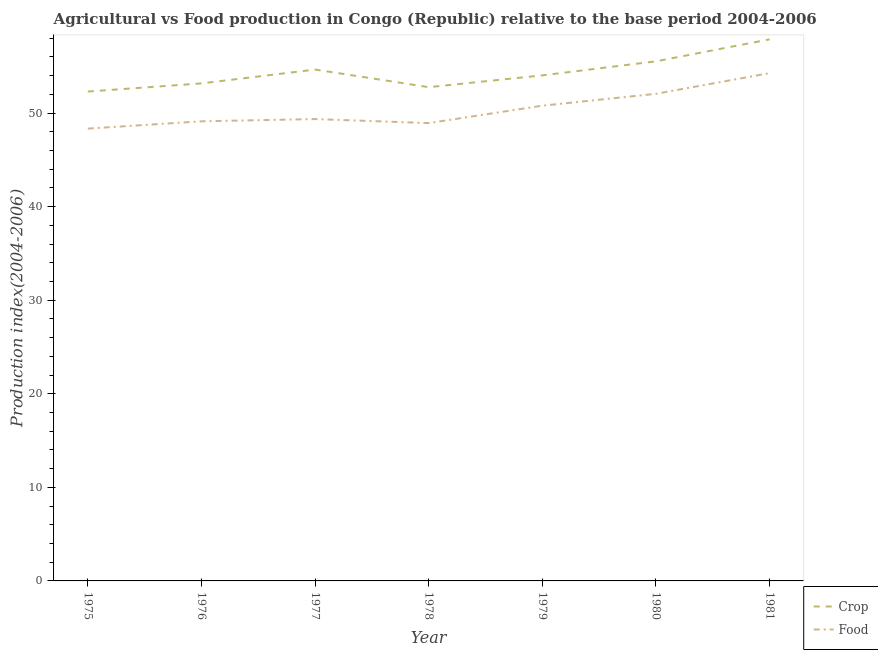Does the line corresponding to food production index intersect with the line corresponding to crop production index?
Provide a short and direct response. No. What is the crop production index in 1975?
Give a very brief answer. 52.3. Across all years, what is the maximum food production index?
Your response must be concise. 54.27. Across all years, what is the minimum food production index?
Ensure brevity in your answer.  48.34. In which year was the crop production index maximum?
Your answer should be very brief. 1981. In which year was the food production index minimum?
Provide a succinct answer. 1975. What is the total crop production index in the graph?
Your response must be concise. 380.33. What is the difference between the crop production index in 1980 and that in 1981?
Make the answer very short. -2.35. What is the difference between the crop production index in 1978 and the food production index in 1975?
Provide a succinct answer. 4.43. What is the average food production index per year?
Give a very brief answer. 50.41. In the year 1978, what is the difference between the food production index and crop production index?
Your response must be concise. -3.84. In how many years, is the crop production index greater than 22?
Make the answer very short. 7. What is the ratio of the crop production index in 1976 to that in 1980?
Keep it short and to the point. 0.96. Is the food production index in 1975 less than that in 1978?
Give a very brief answer. Yes. What is the difference between the highest and the second highest crop production index?
Provide a short and direct response. 2.35. What is the difference between the highest and the lowest crop production index?
Make the answer very short. 5.58. In how many years, is the crop production index greater than the average crop production index taken over all years?
Offer a terse response. 3. How many years are there in the graph?
Your answer should be compact. 7. What is the difference between two consecutive major ticks on the Y-axis?
Your answer should be very brief. 10. Where does the legend appear in the graph?
Offer a very short reply. Bottom right. What is the title of the graph?
Offer a very short reply. Agricultural vs Food production in Congo (Republic) relative to the base period 2004-2006. What is the label or title of the X-axis?
Your answer should be very brief. Year. What is the label or title of the Y-axis?
Your response must be concise. Production index(2004-2006). What is the Production index(2004-2006) in Crop in 1975?
Give a very brief answer. 52.3. What is the Production index(2004-2006) in Food in 1975?
Your answer should be compact. 48.34. What is the Production index(2004-2006) in Crop in 1976?
Make the answer very short. 53.17. What is the Production index(2004-2006) in Food in 1976?
Provide a short and direct response. 49.12. What is the Production index(2004-2006) of Crop in 1977?
Your answer should be very brief. 54.65. What is the Production index(2004-2006) in Food in 1977?
Your answer should be compact. 49.36. What is the Production index(2004-2006) in Crop in 1978?
Offer a terse response. 52.77. What is the Production index(2004-2006) in Food in 1978?
Give a very brief answer. 48.93. What is the Production index(2004-2006) in Crop in 1979?
Provide a succinct answer. 54.03. What is the Production index(2004-2006) of Food in 1979?
Offer a very short reply. 50.79. What is the Production index(2004-2006) in Crop in 1980?
Your response must be concise. 55.53. What is the Production index(2004-2006) of Food in 1980?
Provide a succinct answer. 52.06. What is the Production index(2004-2006) in Crop in 1981?
Keep it short and to the point. 57.88. What is the Production index(2004-2006) in Food in 1981?
Provide a succinct answer. 54.27. Across all years, what is the maximum Production index(2004-2006) of Crop?
Your answer should be compact. 57.88. Across all years, what is the maximum Production index(2004-2006) in Food?
Your answer should be very brief. 54.27. Across all years, what is the minimum Production index(2004-2006) of Crop?
Your response must be concise. 52.3. Across all years, what is the minimum Production index(2004-2006) of Food?
Give a very brief answer. 48.34. What is the total Production index(2004-2006) in Crop in the graph?
Your answer should be very brief. 380.33. What is the total Production index(2004-2006) of Food in the graph?
Ensure brevity in your answer.  352.87. What is the difference between the Production index(2004-2006) in Crop in 1975 and that in 1976?
Your response must be concise. -0.87. What is the difference between the Production index(2004-2006) in Food in 1975 and that in 1976?
Your response must be concise. -0.78. What is the difference between the Production index(2004-2006) in Crop in 1975 and that in 1977?
Offer a terse response. -2.35. What is the difference between the Production index(2004-2006) in Food in 1975 and that in 1977?
Your answer should be very brief. -1.02. What is the difference between the Production index(2004-2006) of Crop in 1975 and that in 1978?
Your answer should be very brief. -0.47. What is the difference between the Production index(2004-2006) in Food in 1975 and that in 1978?
Offer a very short reply. -0.59. What is the difference between the Production index(2004-2006) in Crop in 1975 and that in 1979?
Make the answer very short. -1.73. What is the difference between the Production index(2004-2006) of Food in 1975 and that in 1979?
Provide a short and direct response. -2.45. What is the difference between the Production index(2004-2006) of Crop in 1975 and that in 1980?
Provide a short and direct response. -3.23. What is the difference between the Production index(2004-2006) in Food in 1975 and that in 1980?
Give a very brief answer. -3.72. What is the difference between the Production index(2004-2006) in Crop in 1975 and that in 1981?
Provide a succinct answer. -5.58. What is the difference between the Production index(2004-2006) of Food in 1975 and that in 1981?
Your answer should be compact. -5.93. What is the difference between the Production index(2004-2006) in Crop in 1976 and that in 1977?
Your answer should be very brief. -1.48. What is the difference between the Production index(2004-2006) in Food in 1976 and that in 1977?
Keep it short and to the point. -0.24. What is the difference between the Production index(2004-2006) in Food in 1976 and that in 1978?
Your answer should be very brief. 0.19. What is the difference between the Production index(2004-2006) of Crop in 1976 and that in 1979?
Your answer should be very brief. -0.86. What is the difference between the Production index(2004-2006) in Food in 1976 and that in 1979?
Make the answer very short. -1.67. What is the difference between the Production index(2004-2006) of Crop in 1976 and that in 1980?
Give a very brief answer. -2.36. What is the difference between the Production index(2004-2006) in Food in 1976 and that in 1980?
Provide a succinct answer. -2.94. What is the difference between the Production index(2004-2006) of Crop in 1976 and that in 1981?
Give a very brief answer. -4.71. What is the difference between the Production index(2004-2006) of Food in 1976 and that in 1981?
Keep it short and to the point. -5.15. What is the difference between the Production index(2004-2006) of Crop in 1977 and that in 1978?
Provide a succinct answer. 1.88. What is the difference between the Production index(2004-2006) in Food in 1977 and that in 1978?
Keep it short and to the point. 0.43. What is the difference between the Production index(2004-2006) in Crop in 1977 and that in 1979?
Keep it short and to the point. 0.62. What is the difference between the Production index(2004-2006) of Food in 1977 and that in 1979?
Provide a succinct answer. -1.43. What is the difference between the Production index(2004-2006) in Crop in 1977 and that in 1980?
Provide a short and direct response. -0.88. What is the difference between the Production index(2004-2006) in Food in 1977 and that in 1980?
Your answer should be compact. -2.7. What is the difference between the Production index(2004-2006) in Crop in 1977 and that in 1981?
Provide a succinct answer. -3.23. What is the difference between the Production index(2004-2006) in Food in 1977 and that in 1981?
Your answer should be very brief. -4.91. What is the difference between the Production index(2004-2006) in Crop in 1978 and that in 1979?
Give a very brief answer. -1.26. What is the difference between the Production index(2004-2006) in Food in 1978 and that in 1979?
Provide a short and direct response. -1.86. What is the difference between the Production index(2004-2006) of Crop in 1978 and that in 1980?
Provide a short and direct response. -2.76. What is the difference between the Production index(2004-2006) of Food in 1978 and that in 1980?
Make the answer very short. -3.13. What is the difference between the Production index(2004-2006) in Crop in 1978 and that in 1981?
Your answer should be very brief. -5.11. What is the difference between the Production index(2004-2006) of Food in 1978 and that in 1981?
Give a very brief answer. -5.34. What is the difference between the Production index(2004-2006) in Food in 1979 and that in 1980?
Your response must be concise. -1.27. What is the difference between the Production index(2004-2006) in Crop in 1979 and that in 1981?
Ensure brevity in your answer.  -3.85. What is the difference between the Production index(2004-2006) of Food in 1979 and that in 1981?
Provide a succinct answer. -3.48. What is the difference between the Production index(2004-2006) of Crop in 1980 and that in 1981?
Keep it short and to the point. -2.35. What is the difference between the Production index(2004-2006) of Food in 1980 and that in 1981?
Your answer should be compact. -2.21. What is the difference between the Production index(2004-2006) of Crop in 1975 and the Production index(2004-2006) of Food in 1976?
Give a very brief answer. 3.18. What is the difference between the Production index(2004-2006) of Crop in 1975 and the Production index(2004-2006) of Food in 1977?
Offer a terse response. 2.94. What is the difference between the Production index(2004-2006) of Crop in 1975 and the Production index(2004-2006) of Food in 1978?
Offer a very short reply. 3.37. What is the difference between the Production index(2004-2006) in Crop in 1975 and the Production index(2004-2006) in Food in 1979?
Provide a succinct answer. 1.51. What is the difference between the Production index(2004-2006) in Crop in 1975 and the Production index(2004-2006) in Food in 1980?
Offer a very short reply. 0.24. What is the difference between the Production index(2004-2006) of Crop in 1975 and the Production index(2004-2006) of Food in 1981?
Provide a succinct answer. -1.97. What is the difference between the Production index(2004-2006) in Crop in 1976 and the Production index(2004-2006) in Food in 1977?
Your answer should be very brief. 3.81. What is the difference between the Production index(2004-2006) in Crop in 1976 and the Production index(2004-2006) in Food in 1978?
Provide a short and direct response. 4.24. What is the difference between the Production index(2004-2006) in Crop in 1976 and the Production index(2004-2006) in Food in 1979?
Keep it short and to the point. 2.38. What is the difference between the Production index(2004-2006) in Crop in 1976 and the Production index(2004-2006) in Food in 1980?
Make the answer very short. 1.11. What is the difference between the Production index(2004-2006) in Crop in 1976 and the Production index(2004-2006) in Food in 1981?
Make the answer very short. -1.1. What is the difference between the Production index(2004-2006) of Crop in 1977 and the Production index(2004-2006) of Food in 1978?
Offer a terse response. 5.72. What is the difference between the Production index(2004-2006) of Crop in 1977 and the Production index(2004-2006) of Food in 1979?
Your answer should be very brief. 3.86. What is the difference between the Production index(2004-2006) of Crop in 1977 and the Production index(2004-2006) of Food in 1980?
Your response must be concise. 2.59. What is the difference between the Production index(2004-2006) of Crop in 1977 and the Production index(2004-2006) of Food in 1981?
Your answer should be compact. 0.38. What is the difference between the Production index(2004-2006) in Crop in 1978 and the Production index(2004-2006) in Food in 1979?
Provide a succinct answer. 1.98. What is the difference between the Production index(2004-2006) of Crop in 1978 and the Production index(2004-2006) of Food in 1980?
Provide a succinct answer. 0.71. What is the difference between the Production index(2004-2006) in Crop in 1978 and the Production index(2004-2006) in Food in 1981?
Give a very brief answer. -1.5. What is the difference between the Production index(2004-2006) of Crop in 1979 and the Production index(2004-2006) of Food in 1980?
Provide a succinct answer. 1.97. What is the difference between the Production index(2004-2006) in Crop in 1979 and the Production index(2004-2006) in Food in 1981?
Give a very brief answer. -0.24. What is the difference between the Production index(2004-2006) of Crop in 1980 and the Production index(2004-2006) of Food in 1981?
Provide a short and direct response. 1.26. What is the average Production index(2004-2006) in Crop per year?
Ensure brevity in your answer.  54.33. What is the average Production index(2004-2006) in Food per year?
Give a very brief answer. 50.41. In the year 1975, what is the difference between the Production index(2004-2006) in Crop and Production index(2004-2006) in Food?
Make the answer very short. 3.96. In the year 1976, what is the difference between the Production index(2004-2006) of Crop and Production index(2004-2006) of Food?
Make the answer very short. 4.05. In the year 1977, what is the difference between the Production index(2004-2006) of Crop and Production index(2004-2006) of Food?
Make the answer very short. 5.29. In the year 1978, what is the difference between the Production index(2004-2006) in Crop and Production index(2004-2006) in Food?
Provide a succinct answer. 3.84. In the year 1979, what is the difference between the Production index(2004-2006) of Crop and Production index(2004-2006) of Food?
Offer a terse response. 3.24. In the year 1980, what is the difference between the Production index(2004-2006) in Crop and Production index(2004-2006) in Food?
Offer a terse response. 3.47. In the year 1981, what is the difference between the Production index(2004-2006) in Crop and Production index(2004-2006) in Food?
Your answer should be very brief. 3.61. What is the ratio of the Production index(2004-2006) of Crop in 1975 to that in 1976?
Make the answer very short. 0.98. What is the ratio of the Production index(2004-2006) in Food in 1975 to that in 1976?
Give a very brief answer. 0.98. What is the ratio of the Production index(2004-2006) in Food in 1975 to that in 1977?
Your response must be concise. 0.98. What is the ratio of the Production index(2004-2006) in Crop in 1975 to that in 1978?
Your response must be concise. 0.99. What is the ratio of the Production index(2004-2006) of Food in 1975 to that in 1978?
Ensure brevity in your answer.  0.99. What is the ratio of the Production index(2004-2006) in Food in 1975 to that in 1979?
Offer a terse response. 0.95. What is the ratio of the Production index(2004-2006) of Crop in 1975 to that in 1980?
Keep it short and to the point. 0.94. What is the ratio of the Production index(2004-2006) in Food in 1975 to that in 1980?
Your answer should be very brief. 0.93. What is the ratio of the Production index(2004-2006) of Crop in 1975 to that in 1981?
Ensure brevity in your answer.  0.9. What is the ratio of the Production index(2004-2006) of Food in 1975 to that in 1981?
Give a very brief answer. 0.89. What is the ratio of the Production index(2004-2006) of Crop in 1976 to that in 1977?
Offer a very short reply. 0.97. What is the ratio of the Production index(2004-2006) of Food in 1976 to that in 1977?
Give a very brief answer. 1. What is the ratio of the Production index(2004-2006) of Crop in 1976 to that in 1978?
Make the answer very short. 1.01. What is the ratio of the Production index(2004-2006) in Crop in 1976 to that in 1979?
Ensure brevity in your answer.  0.98. What is the ratio of the Production index(2004-2006) in Food in 1976 to that in 1979?
Give a very brief answer. 0.97. What is the ratio of the Production index(2004-2006) of Crop in 1976 to that in 1980?
Offer a terse response. 0.96. What is the ratio of the Production index(2004-2006) of Food in 1976 to that in 1980?
Your answer should be very brief. 0.94. What is the ratio of the Production index(2004-2006) of Crop in 1976 to that in 1981?
Ensure brevity in your answer.  0.92. What is the ratio of the Production index(2004-2006) in Food in 1976 to that in 1981?
Your response must be concise. 0.91. What is the ratio of the Production index(2004-2006) of Crop in 1977 to that in 1978?
Make the answer very short. 1.04. What is the ratio of the Production index(2004-2006) in Food in 1977 to that in 1978?
Offer a terse response. 1.01. What is the ratio of the Production index(2004-2006) in Crop in 1977 to that in 1979?
Make the answer very short. 1.01. What is the ratio of the Production index(2004-2006) in Food in 1977 to that in 1979?
Make the answer very short. 0.97. What is the ratio of the Production index(2004-2006) of Crop in 1977 to that in 1980?
Give a very brief answer. 0.98. What is the ratio of the Production index(2004-2006) of Food in 1977 to that in 1980?
Your answer should be very brief. 0.95. What is the ratio of the Production index(2004-2006) of Crop in 1977 to that in 1981?
Provide a short and direct response. 0.94. What is the ratio of the Production index(2004-2006) of Food in 1977 to that in 1981?
Give a very brief answer. 0.91. What is the ratio of the Production index(2004-2006) in Crop in 1978 to that in 1979?
Provide a short and direct response. 0.98. What is the ratio of the Production index(2004-2006) of Food in 1978 to that in 1979?
Provide a short and direct response. 0.96. What is the ratio of the Production index(2004-2006) of Crop in 1978 to that in 1980?
Your answer should be compact. 0.95. What is the ratio of the Production index(2004-2006) in Food in 1978 to that in 1980?
Offer a terse response. 0.94. What is the ratio of the Production index(2004-2006) in Crop in 1978 to that in 1981?
Provide a succinct answer. 0.91. What is the ratio of the Production index(2004-2006) in Food in 1978 to that in 1981?
Offer a terse response. 0.9. What is the ratio of the Production index(2004-2006) in Crop in 1979 to that in 1980?
Make the answer very short. 0.97. What is the ratio of the Production index(2004-2006) in Food in 1979 to that in 1980?
Offer a very short reply. 0.98. What is the ratio of the Production index(2004-2006) of Crop in 1979 to that in 1981?
Provide a short and direct response. 0.93. What is the ratio of the Production index(2004-2006) in Food in 1979 to that in 1981?
Give a very brief answer. 0.94. What is the ratio of the Production index(2004-2006) in Crop in 1980 to that in 1981?
Offer a terse response. 0.96. What is the ratio of the Production index(2004-2006) of Food in 1980 to that in 1981?
Make the answer very short. 0.96. What is the difference between the highest and the second highest Production index(2004-2006) of Crop?
Provide a short and direct response. 2.35. What is the difference between the highest and the second highest Production index(2004-2006) of Food?
Give a very brief answer. 2.21. What is the difference between the highest and the lowest Production index(2004-2006) in Crop?
Your answer should be compact. 5.58. What is the difference between the highest and the lowest Production index(2004-2006) of Food?
Make the answer very short. 5.93. 